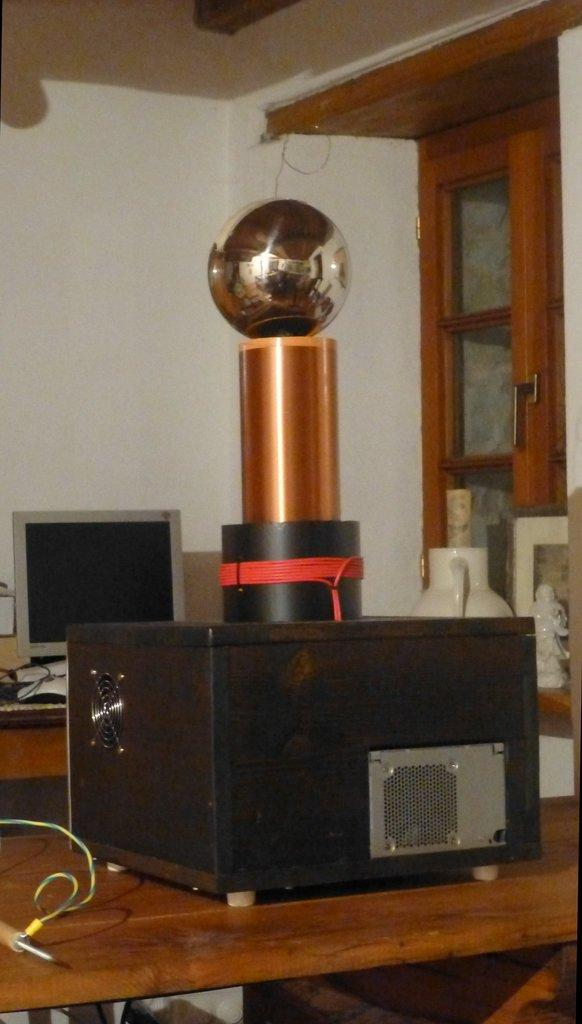What is the main piece of furniture in the image? There is a table in the image. What is placed on the table? There is a desktop, a machine, decorations, and a glass jug on the table. Can you describe the background of the image? There are windows and walls in the background of the image. What type of quilt is draped over the machine on the table? There is no quilt present in the image; only the desktop, machine, decorations, and glass jug are visible on the table. 